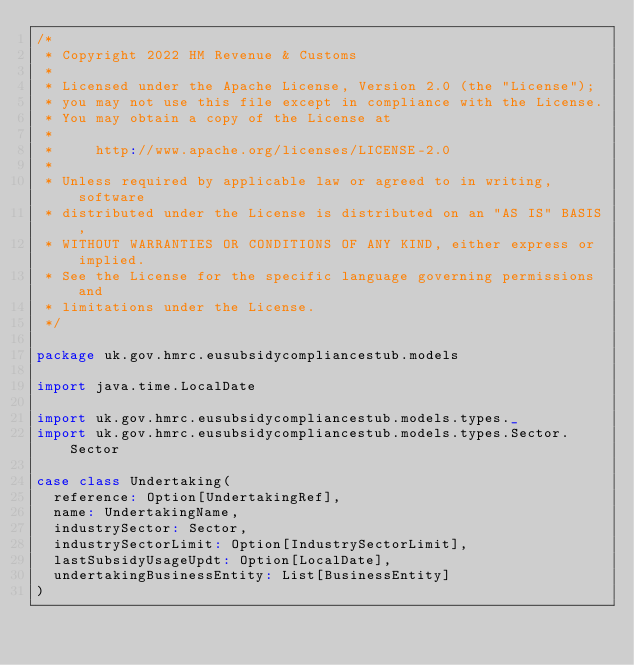Convert code to text. <code><loc_0><loc_0><loc_500><loc_500><_Scala_>/*
 * Copyright 2022 HM Revenue & Customs
 *
 * Licensed under the Apache License, Version 2.0 (the "License");
 * you may not use this file except in compliance with the License.
 * You may obtain a copy of the License at
 *
 *     http://www.apache.org/licenses/LICENSE-2.0
 *
 * Unless required by applicable law or agreed to in writing, software
 * distributed under the License is distributed on an "AS IS" BASIS,
 * WITHOUT WARRANTIES OR CONDITIONS OF ANY KIND, either express or implied.
 * See the License for the specific language governing permissions and
 * limitations under the License.
 */

package uk.gov.hmrc.eusubsidycompliancestub.models

import java.time.LocalDate

import uk.gov.hmrc.eusubsidycompliancestub.models.types._
import uk.gov.hmrc.eusubsidycompliancestub.models.types.Sector.Sector

case class Undertaking(
  reference: Option[UndertakingRef],
  name: UndertakingName,
  industrySector: Sector,
  industrySectorLimit: Option[IndustrySectorLimit],
  lastSubsidyUsageUpdt: Option[LocalDate],
  undertakingBusinessEntity: List[BusinessEntity]
)
</code> 